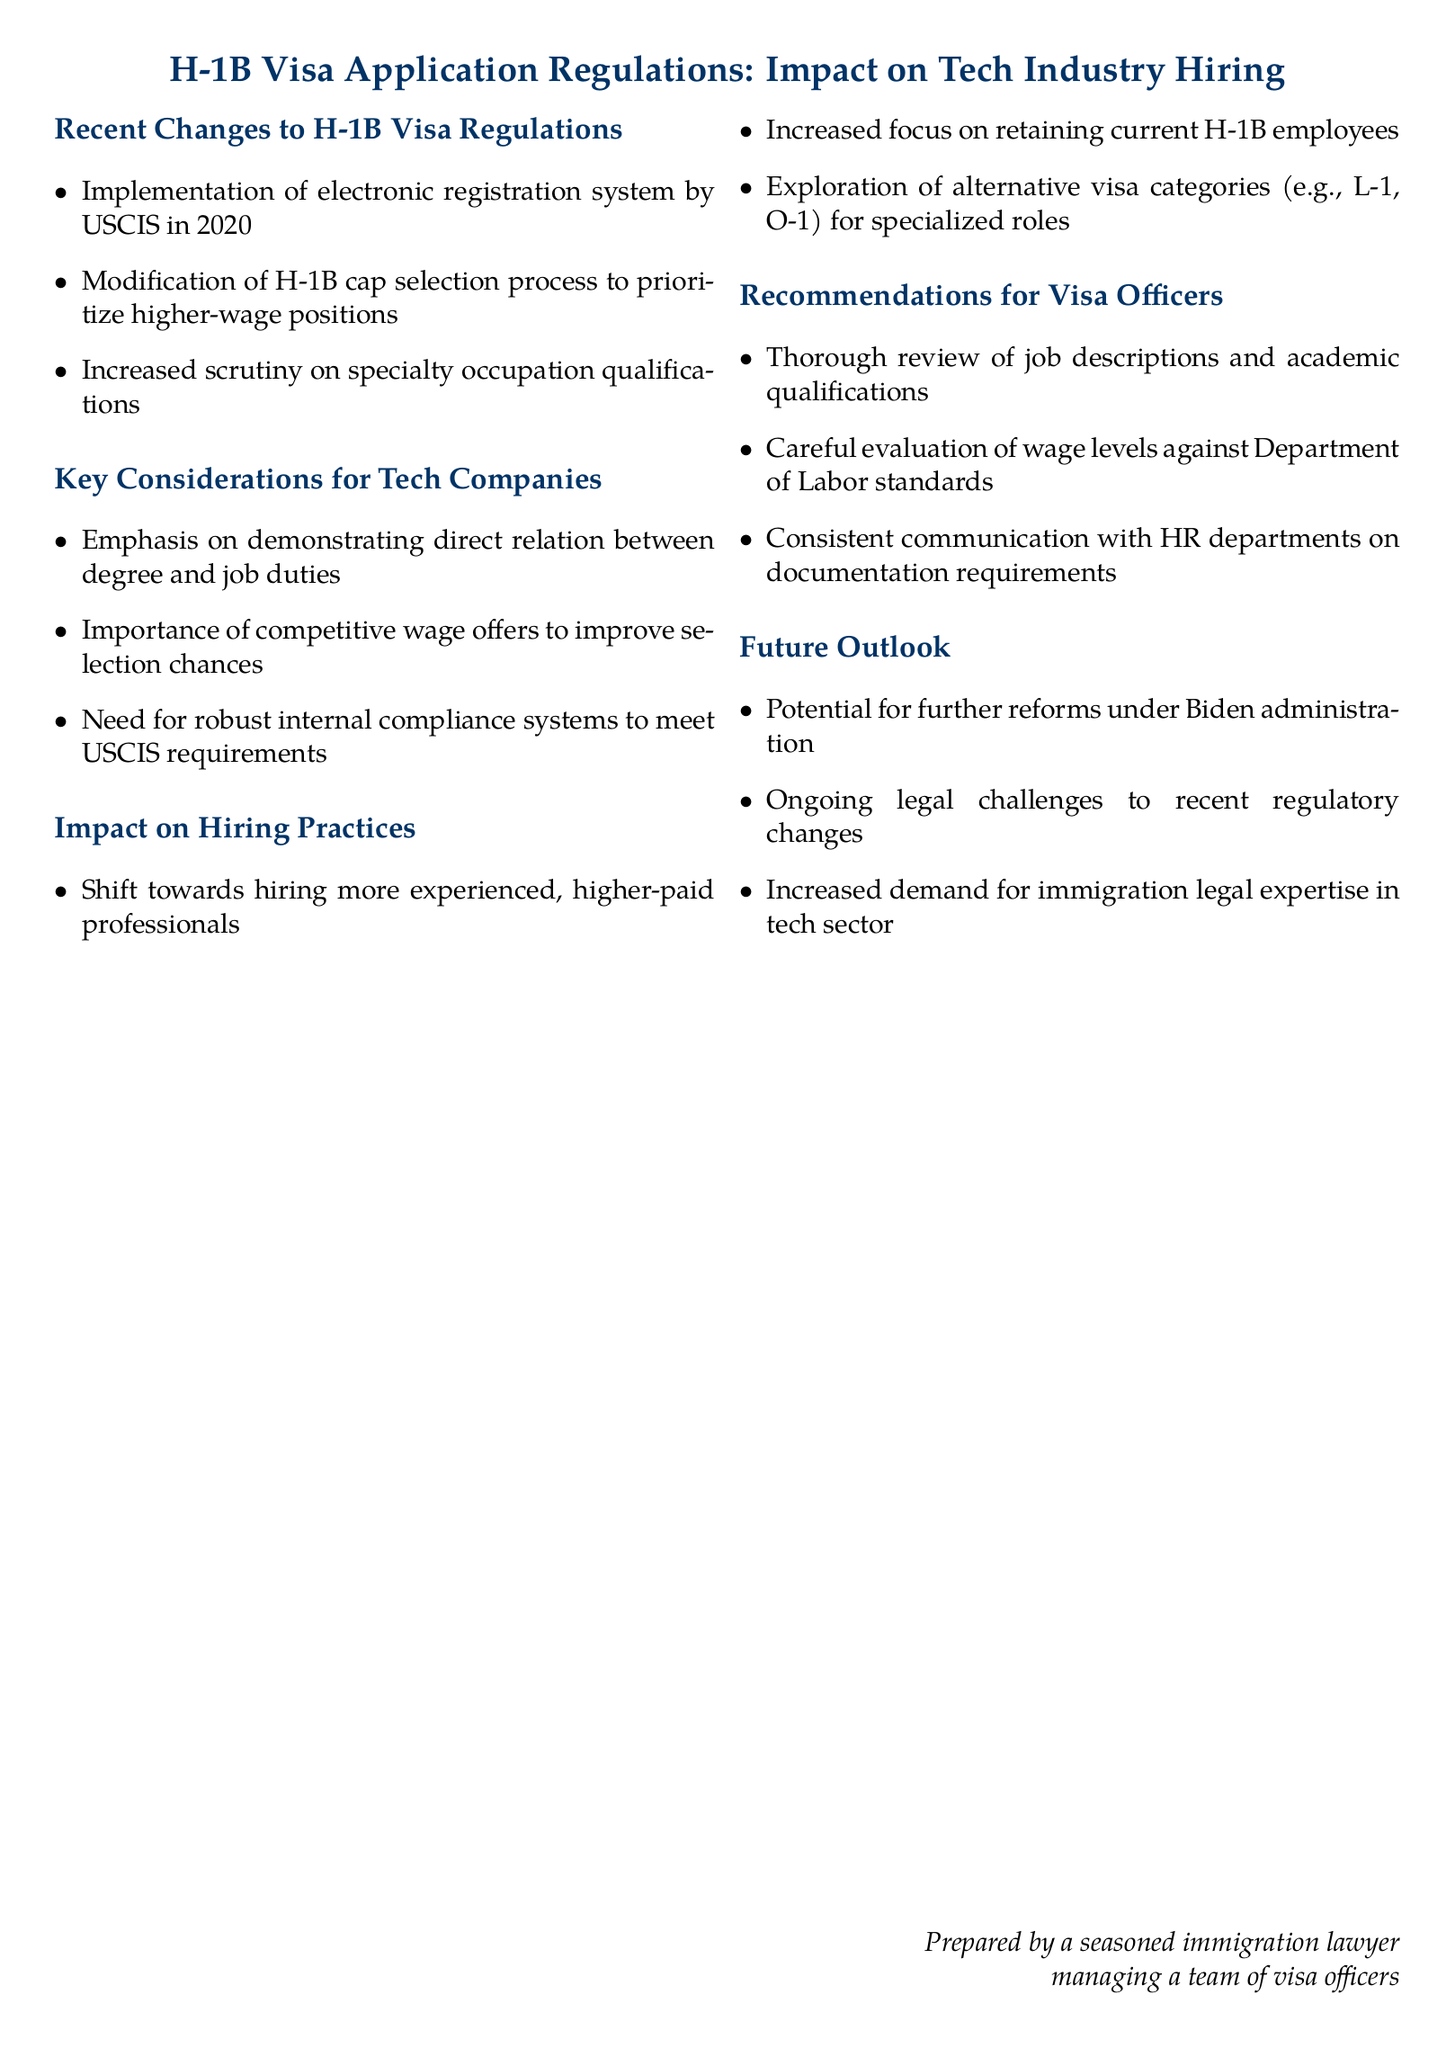What year was the electronic registration system for H-1B visas implemented? The document states that the electronic registration system was implemented by USCIS in 2020.
Answer: 2020 What is prioritized in the modified H-1B cap selection process? The modification of the H-1B cap selection process is aimed at prioritizing higher-wage positions.
Answer: Higher-wage positions What should tech companies demonstrate regarding degree qualifications? Tech companies need to emphasize demonstrating a direct relation between the degree and job duties.
Answer: Direct relation What alternative visa categories may be explored by companies? Companies may explore alternative visa categories such as L-1 and O-1 for specialized roles.
Answer: L-1, O-1 What is a recommendation for visa officers regarding job descriptions? Visa officers are recommended to conduct a thorough review of job descriptions and academic qualifications.
Answer: Thorough review What future aspect might increase demand for immigration legal expertise in the tech sector? The document indicates that there will be increased demand for immigration legal expertise due to ongoing legal challenges to recent regulatory changes.
Answer: Ongoing legal challenges 